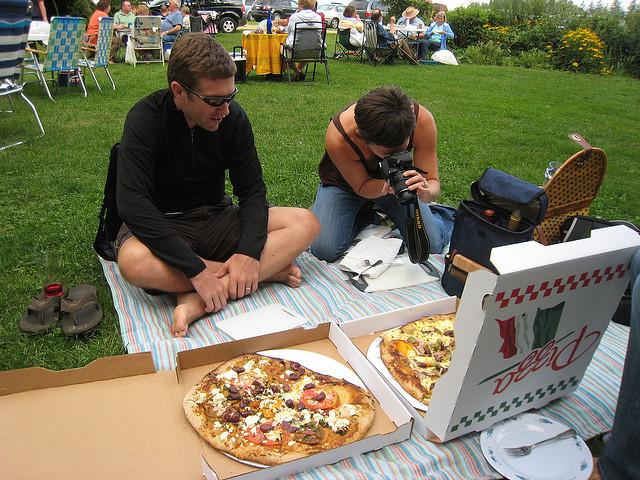Is the lady taking a picture of the pizza?
Concise answer only. Yes. What is the man not wearing?
Answer briefly. Shoes. Is the pizza good?
Concise answer only. Yes. 